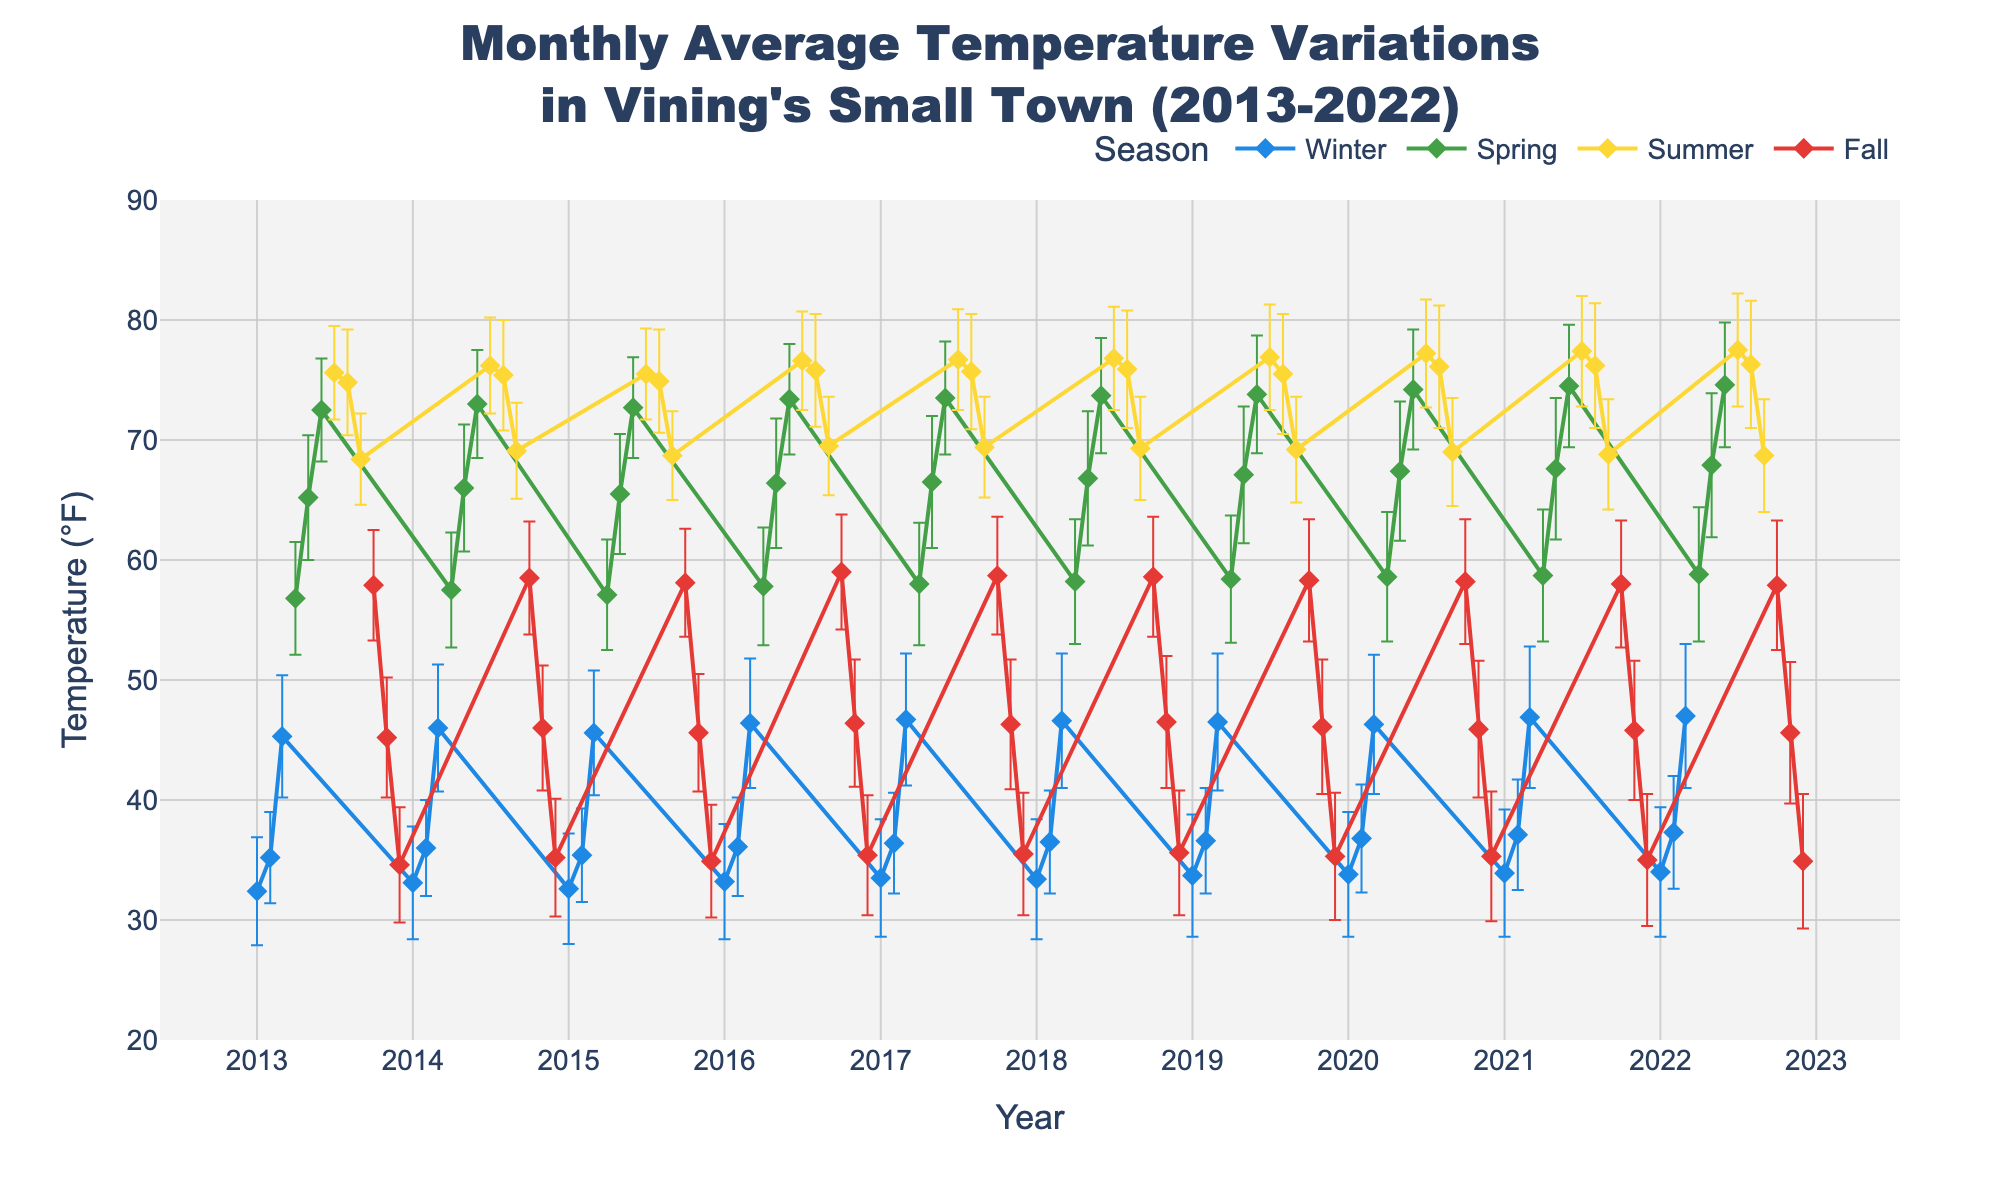What is the title of the figure? The title is prominently displayed at the top of the figure and reads "Monthly Average Temperature Variations in Vining's Small Town (2013-2022)"
Answer: Monthly Average Temperature Variations in Vining's Small Town (2013-2022) What does the x-axis represent? The x-axis represents the time in years, with ticks indicating every year from 2013 to 2022
Answer: Year How are the seasons color-coded in the figure? The seasons are color-coded as follows: Winter is blue, Spring is green, Summer is yellow, and Fall is red. This is indicated by the legend next to the plot
Answer: Winter: blue, Spring: green, Summer: yellow, Fall: red Which season shows the highest peak in temperature? By observing the lines representing each season, Summer has the highest peak temperature, around 77.5°F in July 2022
Answer: Summer During which month does Winter begin to transition to Spring according to the color change on the figure? Winter transitions to Spring around March, as indicated by the change from blue (Winter) to green (Spring)
Answer: March Which year has the hottest July? By examining the peaks for each July, the highest temperature for July occurs in 2022, with a temperature of 77.5°F
Answer: 2022 Which season has the highest variability in temperature, as indicated by the error bars? The length of the error bars reflects variability; Winter has the longest error bars, indicating the highest variability in temperature
Answer: Winter What is the average temperature difference between January 2013 and January 2022? January 2013 has an average temperature of 32.4°F and January 2022 has an average temperature of 34.0°F. The difference is 34.0 - 32.4 = 1.6°F
Answer: 1.6°F During the time frame of the data, in which month does Fall consistently end? Fall consistently ends in November, as indicated by the red color changing to blue, marking the start of Winter
Answer: November Compare the average temperatures for July in 2013 and 2022. Which year was warmer and by how much? The temperature in July 2013 is 75.6°F, and in July 2022, it is 77.5°F. The difference is 77.5 - 75.6 = 1.9°F, making 2022 warmer
Answer: 2022 by 1.9°F 